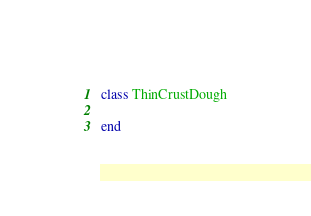<code> <loc_0><loc_0><loc_500><loc_500><_Ruby_>class ThinCrustDough

end
</code> 